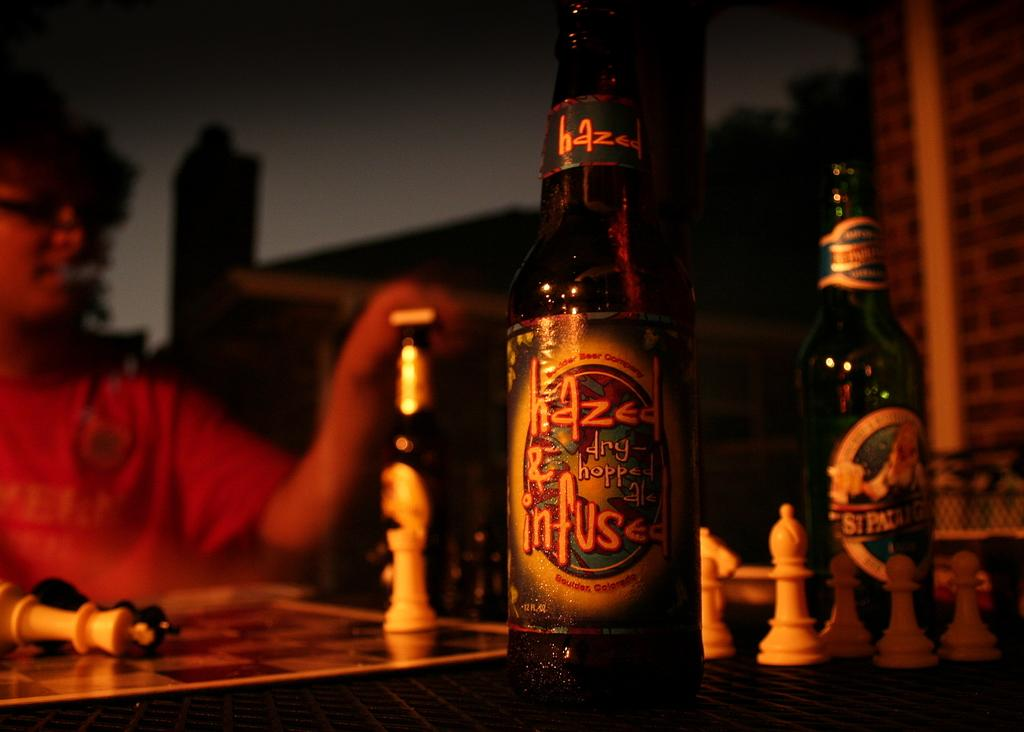Who or what is present in the image? There is a person in the image. What activity is the person engaged in? The person is playing chess, as evidenced by the presence of a chess board and chess pieces in the image. What else can be seen in the image besides the person and chess-related items? There are bottles in the image. How would you describe the background of the image? The background of the image is blurry and dark and dark. What type of spark can be seen coming from the kite in the image? There is no kite present in the image, so no spark can be observed. 